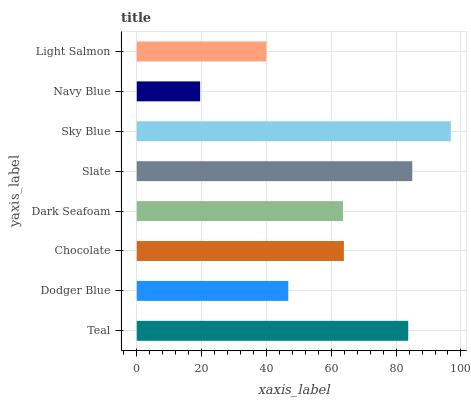Is Navy Blue the minimum?
Answer yes or no. Yes. Is Sky Blue the maximum?
Answer yes or no. Yes. Is Dodger Blue the minimum?
Answer yes or no. No. Is Dodger Blue the maximum?
Answer yes or no. No. Is Teal greater than Dodger Blue?
Answer yes or no. Yes. Is Dodger Blue less than Teal?
Answer yes or no. Yes. Is Dodger Blue greater than Teal?
Answer yes or no. No. Is Teal less than Dodger Blue?
Answer yes or no. No. Is Chocolate the high median?
Answer yes or no. Yes. Is Dark Seafoam the low median?
Answer yes or no. Yes. Is Dodger Blue the high median?
Answer yes or no. No. Is Navy Blue the low median?
Answer yes or no. No. 